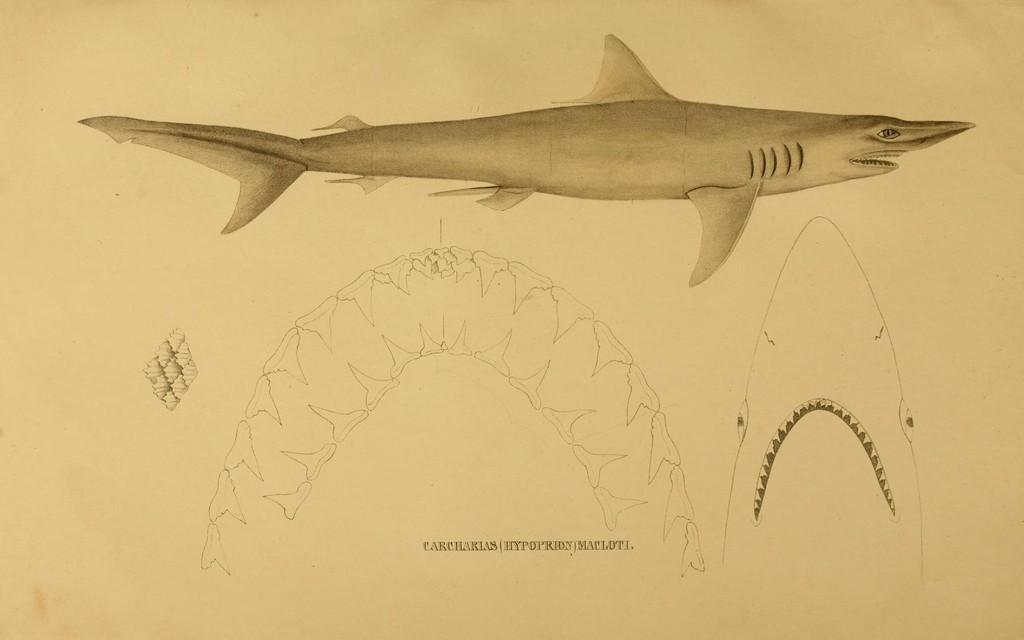Describe this image in one or two sentences. In this image we can see depiction of shark. 